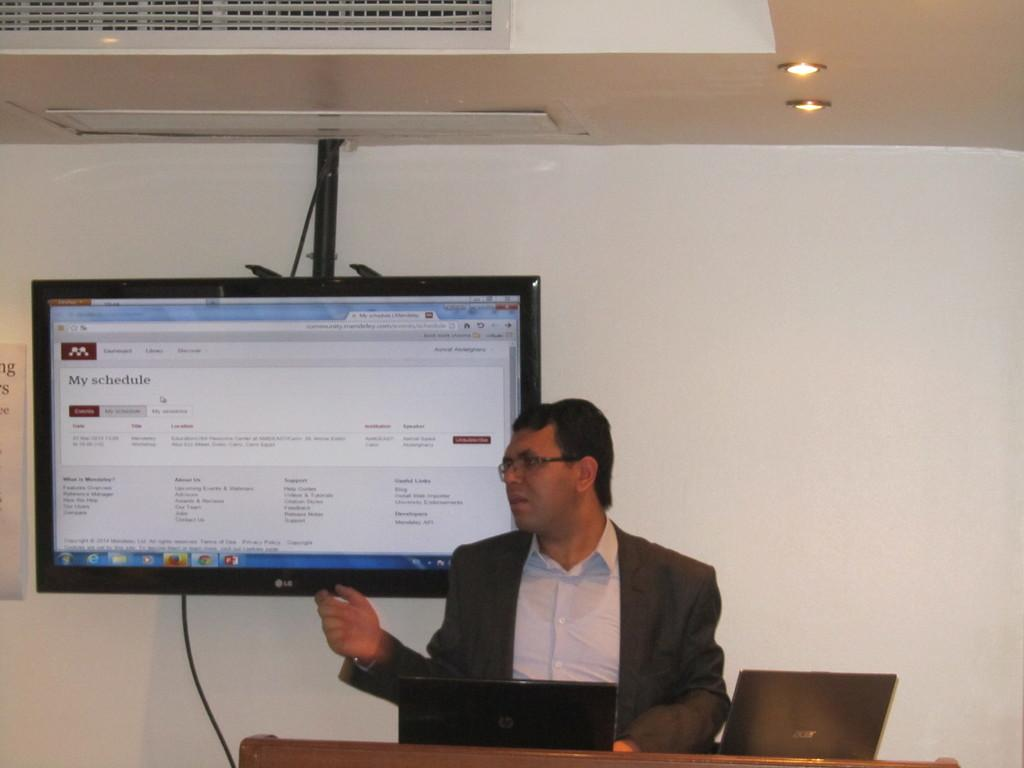<image>
Provide a brief description of the given image. A person is shown with a computer screen of a My Schedule utility app on the screen. 